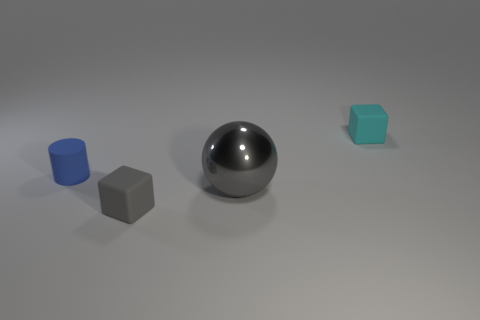Subtract all gray cubes. How many cubes are left? 1 Add 1 large green rubber cubes. How many objects exist? 5 Subtract all balls. How many objects are left? 3 Subtract all green cylinders. How many cyan cubes are left? 1 Subtract all matte cubes. Subtract all tiny brown cylinders. How many objects are left? 2 Add 1 blue things. How many blue things are left? 2 Add 3 small matte cylinders. How many small matte cylinders exist? 4 Subtract 0 brown cylinders. How many objects are left? 4 Subtract all gray cylinders. Subtract all cyan balls. How many cylinders are left? 1 